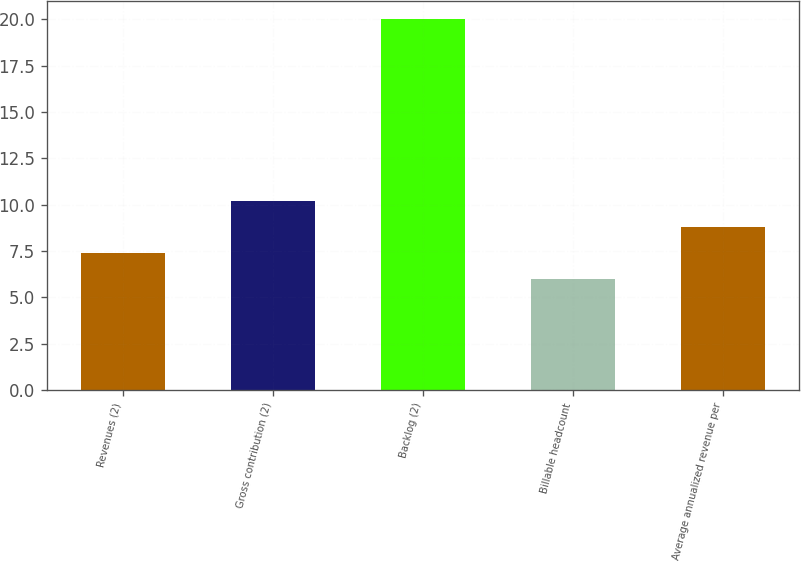Convert chart. <chart><loc_0><loc_0><loc_500><loc_500><bar_chart><fcel>Revenues (2)<fcel>Gross contribution (2)<fcel>Backlog (2)<fcel>Billable headcount<fcel>Average annualized revenue per<nl><fcel>7.4<fcel>10.2<fcel>20<fcel>6<fcel>8.8<nl></chart> 